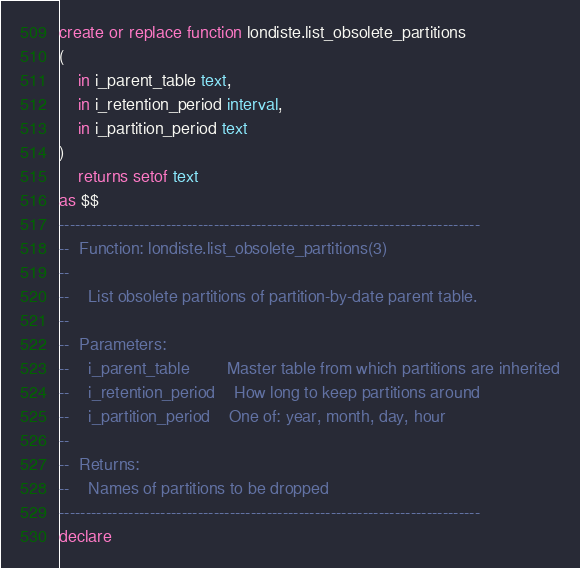<code> <loc_0><loc_0><loc_500><loc_500><_SQL_>
create or replace function londiste.list_obsolete_partitions
(
    in i_parent_table text,
    in i_retention_period interval,
    in i_partition_period text
)
    returns setof text
as $$
-------------------------------------------------------------------------------
--  Function: londiste.list_obsolete_partitions(3)
--
--    List obsolete partitions of partition-by-date parent table.
--
--  Parameters:
--    i_parent_table        Master table from which partitions are inherited
--    i_retention_period    How long to keep partitions around
--    i_partition_period    One of: year, month, day, hour
--
--  Returns:
--    Names of partitions to be dropped
-------------------------------------------------------------------------------
declare</code> 